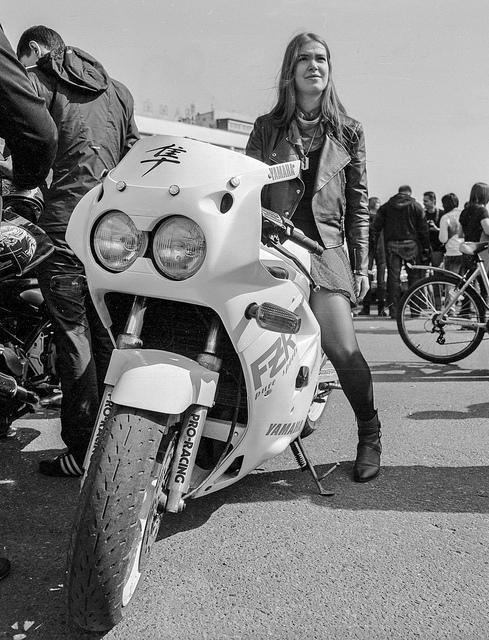How many motorcycles can be seen?
Give a very brief answer. 2. How many people are there?
Give a very brief answer. 4. How many of the birds are sitting?
Give a very brief answer. 0. 